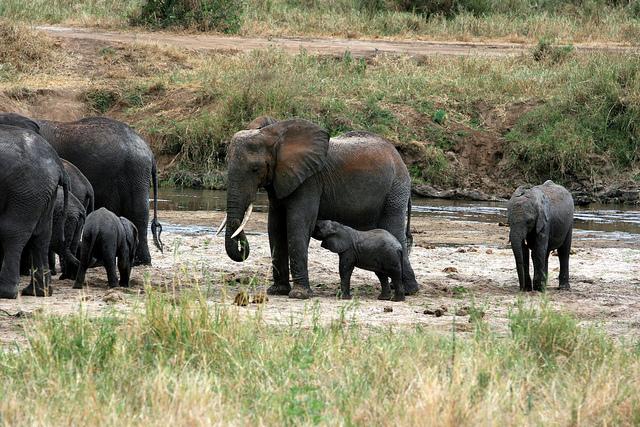How many baby elephants are in the photo?
Give a very brief answer. 3. Are the elephants in the water?
Concise answer only. No. What is the baby elephant in the center doing?
Write a very short answer. Feeding. 